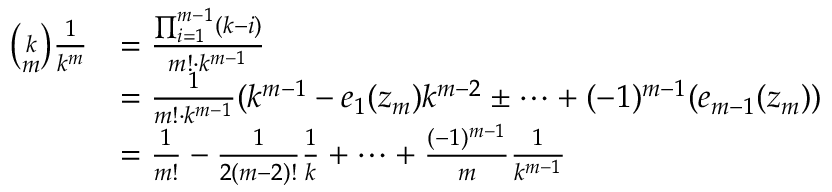Convert formula to latex. <formula><loc_0><loc_0><loc_500><loc_500>\begin{array} { r l } { { \binom { k } { m } } \frac { 1 } { k ^ { m } } } & { = \frac { \prod _ { i = 1 } ^ { m - 1 } ( k - i ) } { m ! \cdot k ^ { m - 1 } } } \\ & { = \frac { 1 } { m ! \cdot k ^ { m - 1 } } ( k ^ { m - 1 } - e _ { 1 } ( z _ { m } ) k ^ { m - 2 } \pm \cdots + ( - 1 ) ^ { m - 1 } ( e _ { m - 1 } ( z _ { m } ) ) } \\ & { = \frac { 1 } { m ! } - \frac { 1 } { 2 ( m - 2 ) ! } \frac { 1 } { k } + \cdots + \frac { ( - 1 ) ^ { m - 1 } } { m } \frac { 1 } { k ^ { m - 1 } } } \end{array}</formula> 